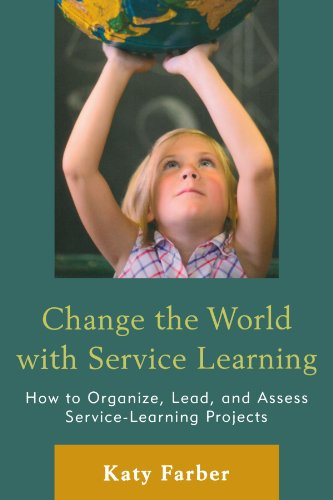What type of book is this? This is an educational guide focused on service learning. It provides step-by-step instructions and strategies about organizing, leading, and evaluating service learning projects. 